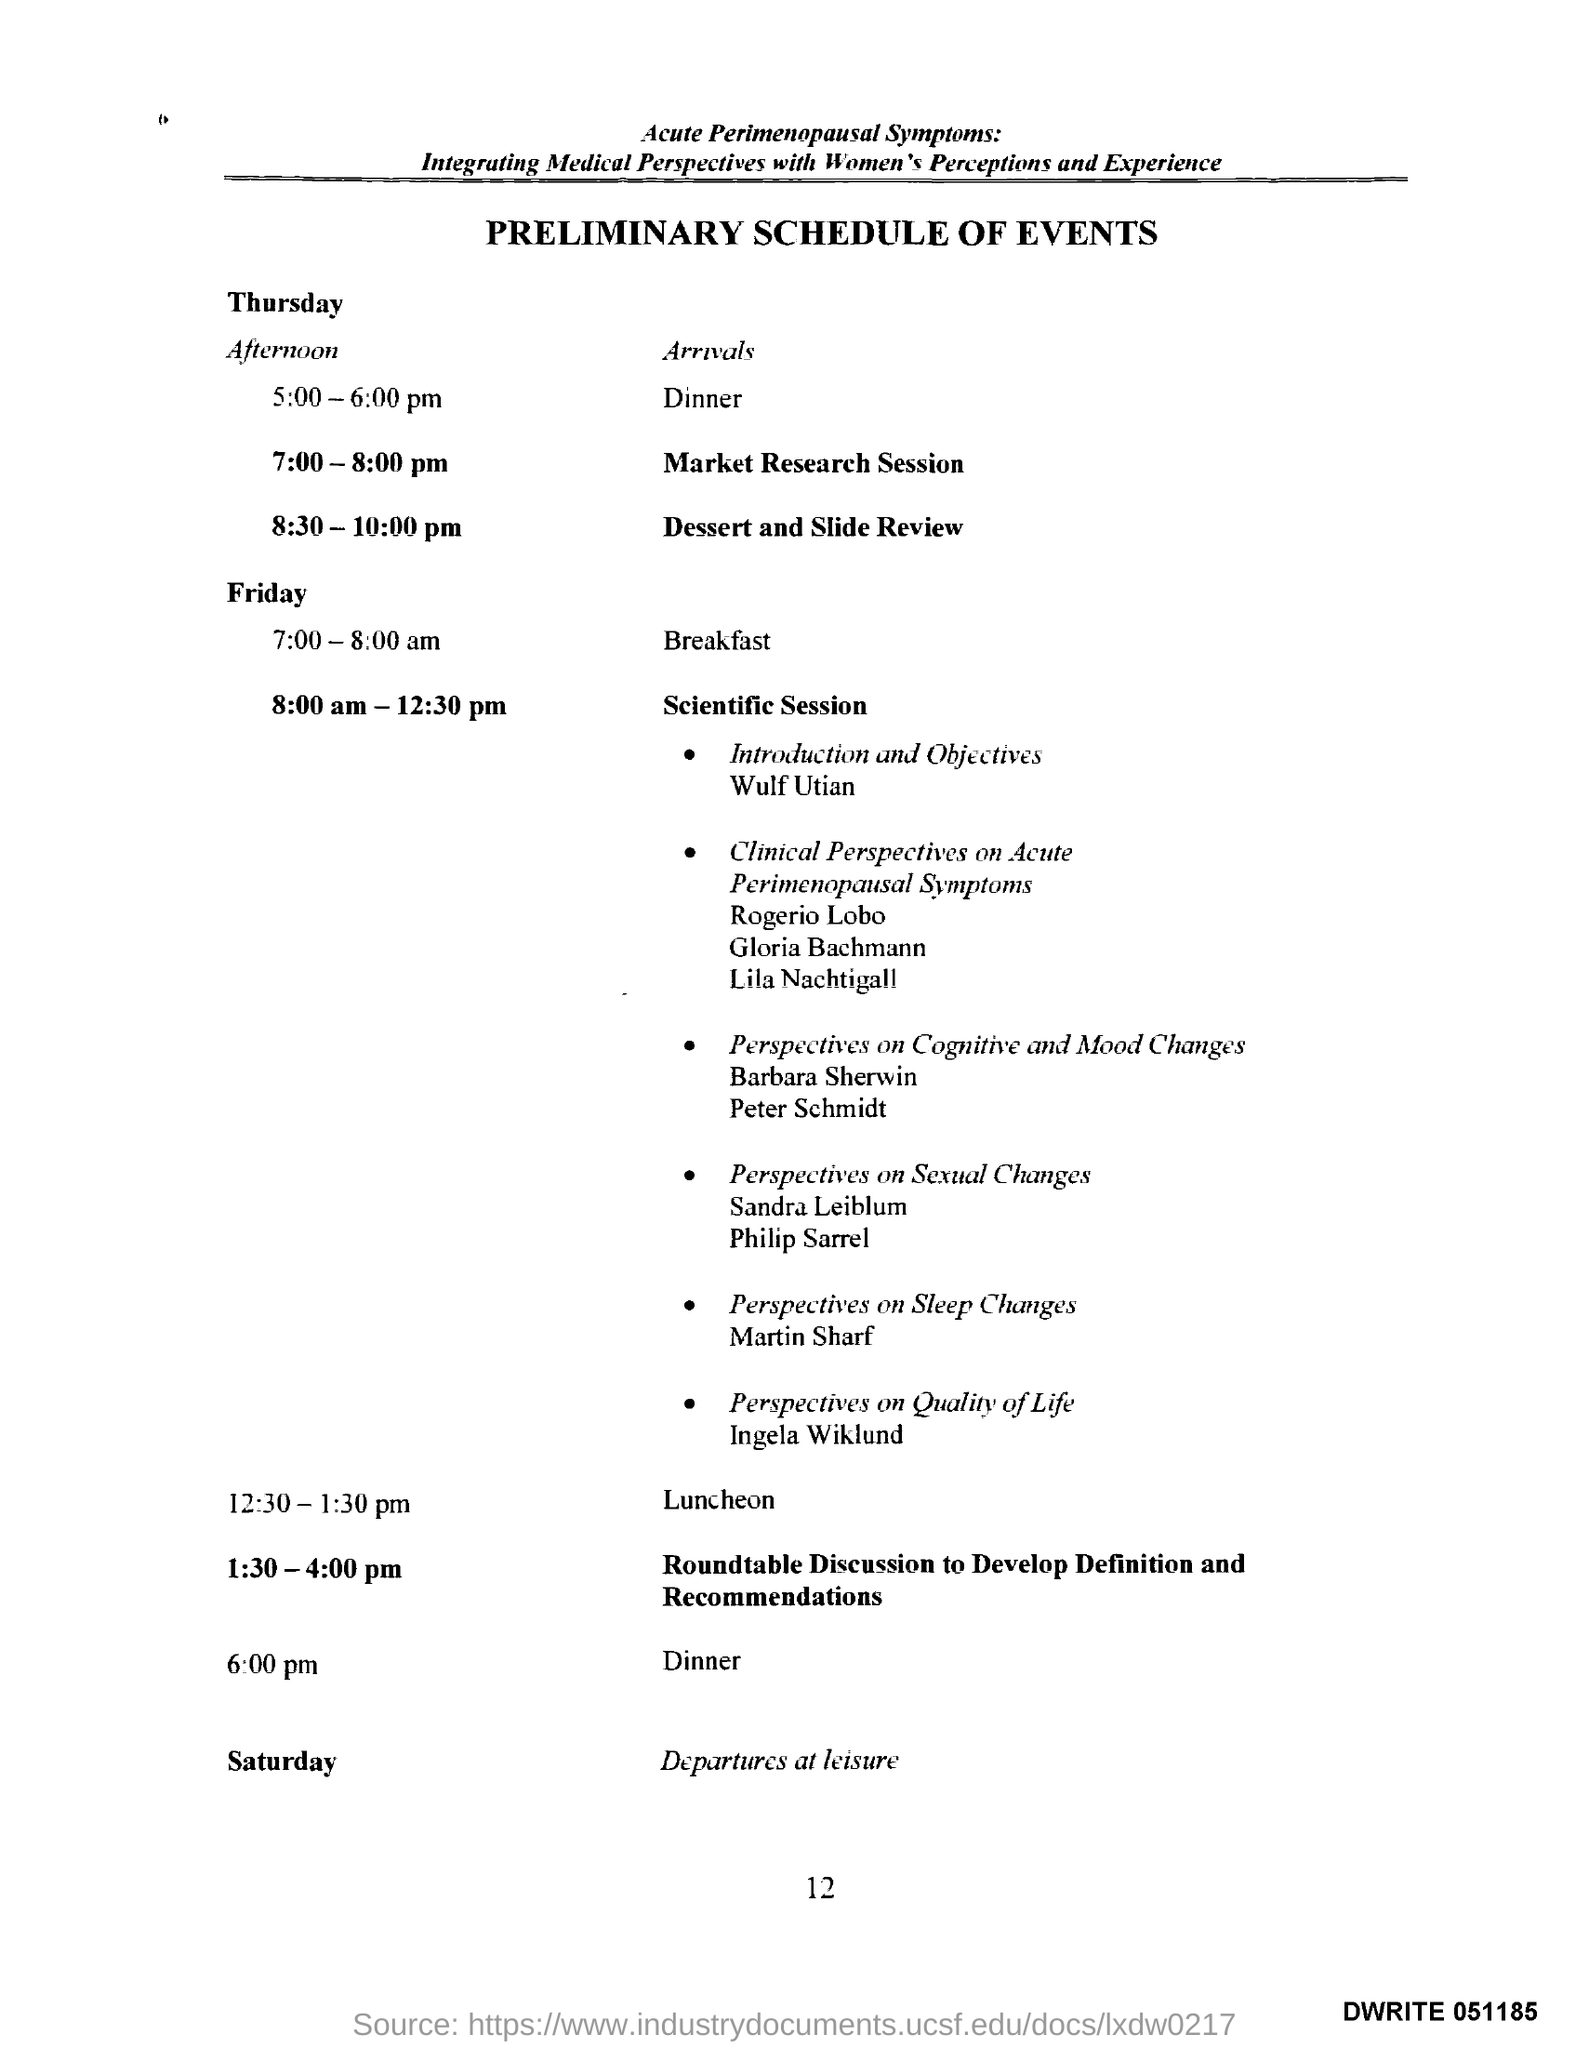What is the heading of the document?
Provide a succinct answer. Preliminary schedule of events. On which day is Departures at leisure scheduled?
Offer a terse response. Saturday. Which session is scheduled to Friday 8:00 am-12:30 pm?
Make the answer very short. Scientific Session. 